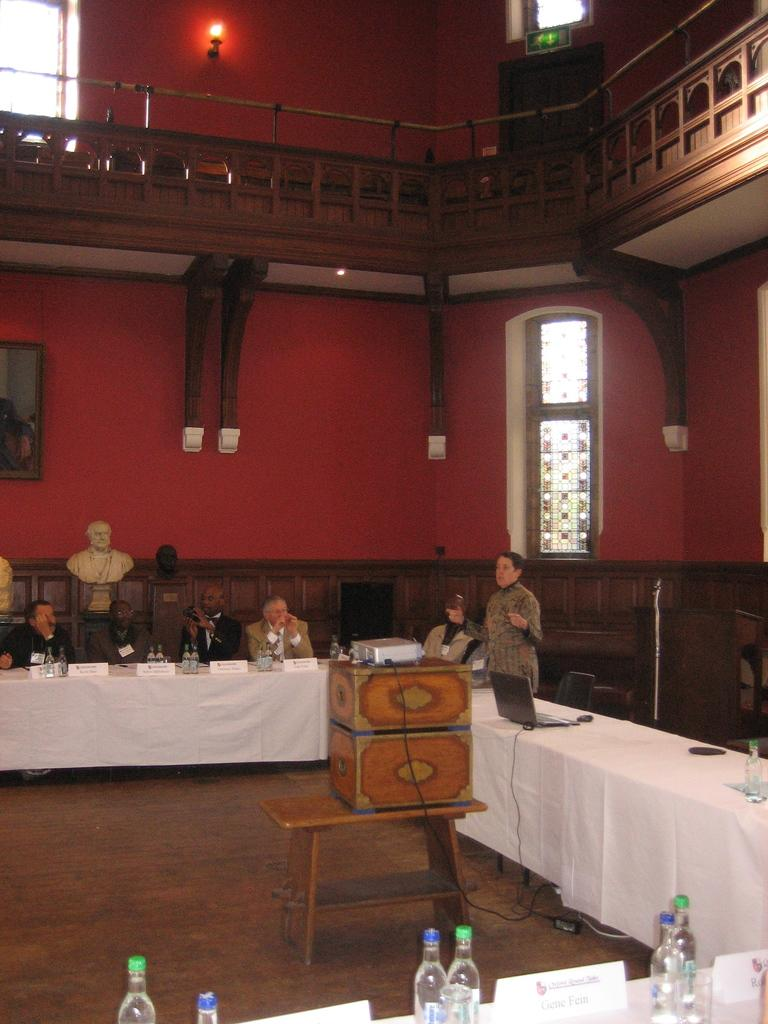What are the people in the image doing? The people in the image are sitting on a table. What is the color of the table? The table is white in color. What can be seen in the background of the image? There is a red color wall in the background of the image. What degree does the bottle have in the image? There is no bottle present in the image, so it cannot have a degree. 